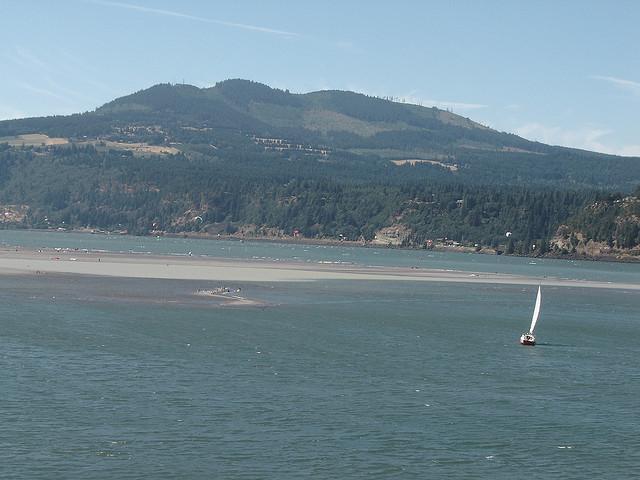How many boats can be seen?
Give a very brief answer. 1. How many people are parasailing?
Give a very brief answer. 1. How many people are wearing helmets?
Give a very brief answer. 0. 